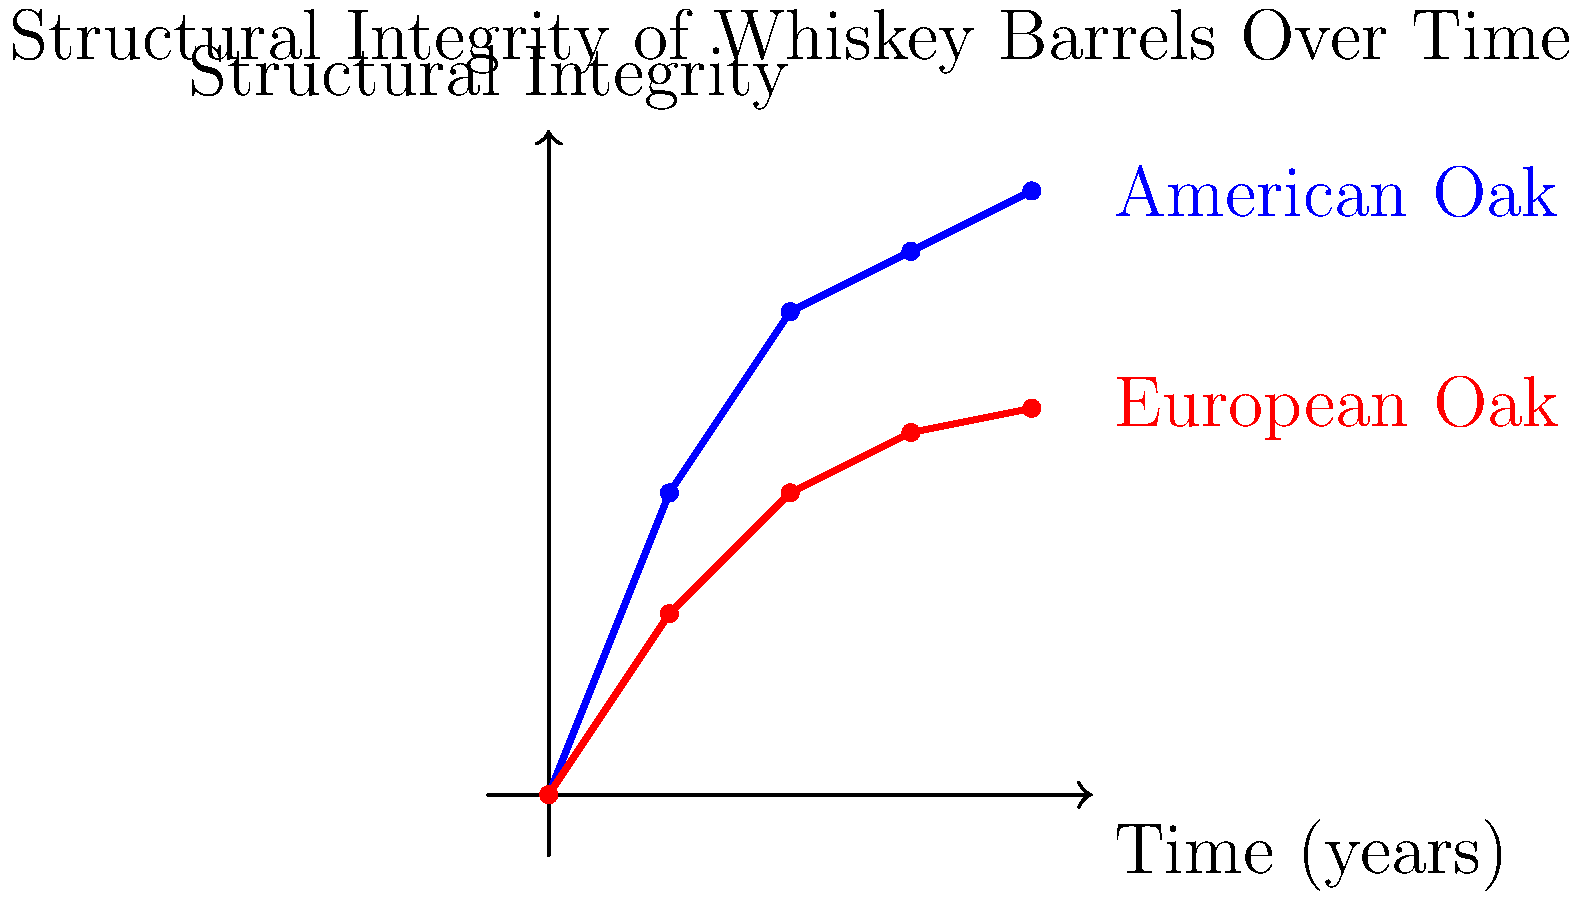As a whiskey enthusiast with a keen interest in engineering, you're analyzing the structural integrity of different types of whiskey barrels over time. Based on the graph, which shows the performance of American Oak and European Oak barrels, calculate the percentage difference in structural integrity between the two types of barrels after 4 years of aging. How might this difference impact the flavor profile of the whiskey, and what martial arts analogy could you use to explain this phenomenon? To solve this problem, let's break it down step-by-step:

1. Identify the structural integrity values at 4 years:
   American Oak: 5.0
   European Oak: 3.2

2. Calculate the difference in structural integrity:
   $\text{Difference} = 5.0 - 3.2 = 1.8$

3. Calculate the percentage difference:
   $\text{Percentage Difference} = \frac{\text{Difference}}{\text{Average}} \times 100\%$
   $\text{Average} = \frac{5.0 + 3.2}{2} = 4.1$
   $\text{Percentage Difference} = \frac{1.8}{4.1} \times 100\% \approx 43.9\%$

4. Impact on flavor profile:
   The higher structural integrity of American Oak barrels suggests they may allow less oxygen interaction, resulting in a slower maturation process and potentially preserving more of the original spirit character. European Oak barrels, with lower structural integrity, may allow more oxygen interaction, leading to faster maturation and potentially more complex flavors.

5. Martial arts analogy:
   This difference can be likened to the contrasting styles of a rigid, structured martial art like Karate (American Oak) versus a more fluid, adaptive style like Jiu-Jitsu (European Oak). The Karate-like American Oak maintains its form more strictly, preserving the original characteristics of the whiskey, while the Jiu-Jitsu-like European Oak adapts and allows for more interaction, potentially resulting in a more complex flavor profile.
Answer: 43.9% difference; American Oak preserves original character, European Oak allows more complexity, similar to Karate vs. Jiu-Jitsu styles. 